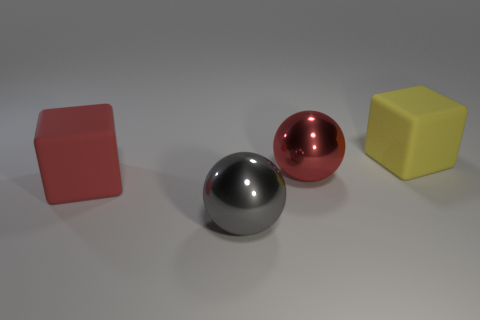Add 4 big red spheres. How many objects exist? 8 Add 1 yellow matte things. How many yellow matte things are left? 2 Add 3 red objects. How many red objects exist? 5 Subtract 0 red cylinders. How many objects are left? 4 Subtract all gray spheres. Subtract all yellow matte things. How many objects are left? 2 